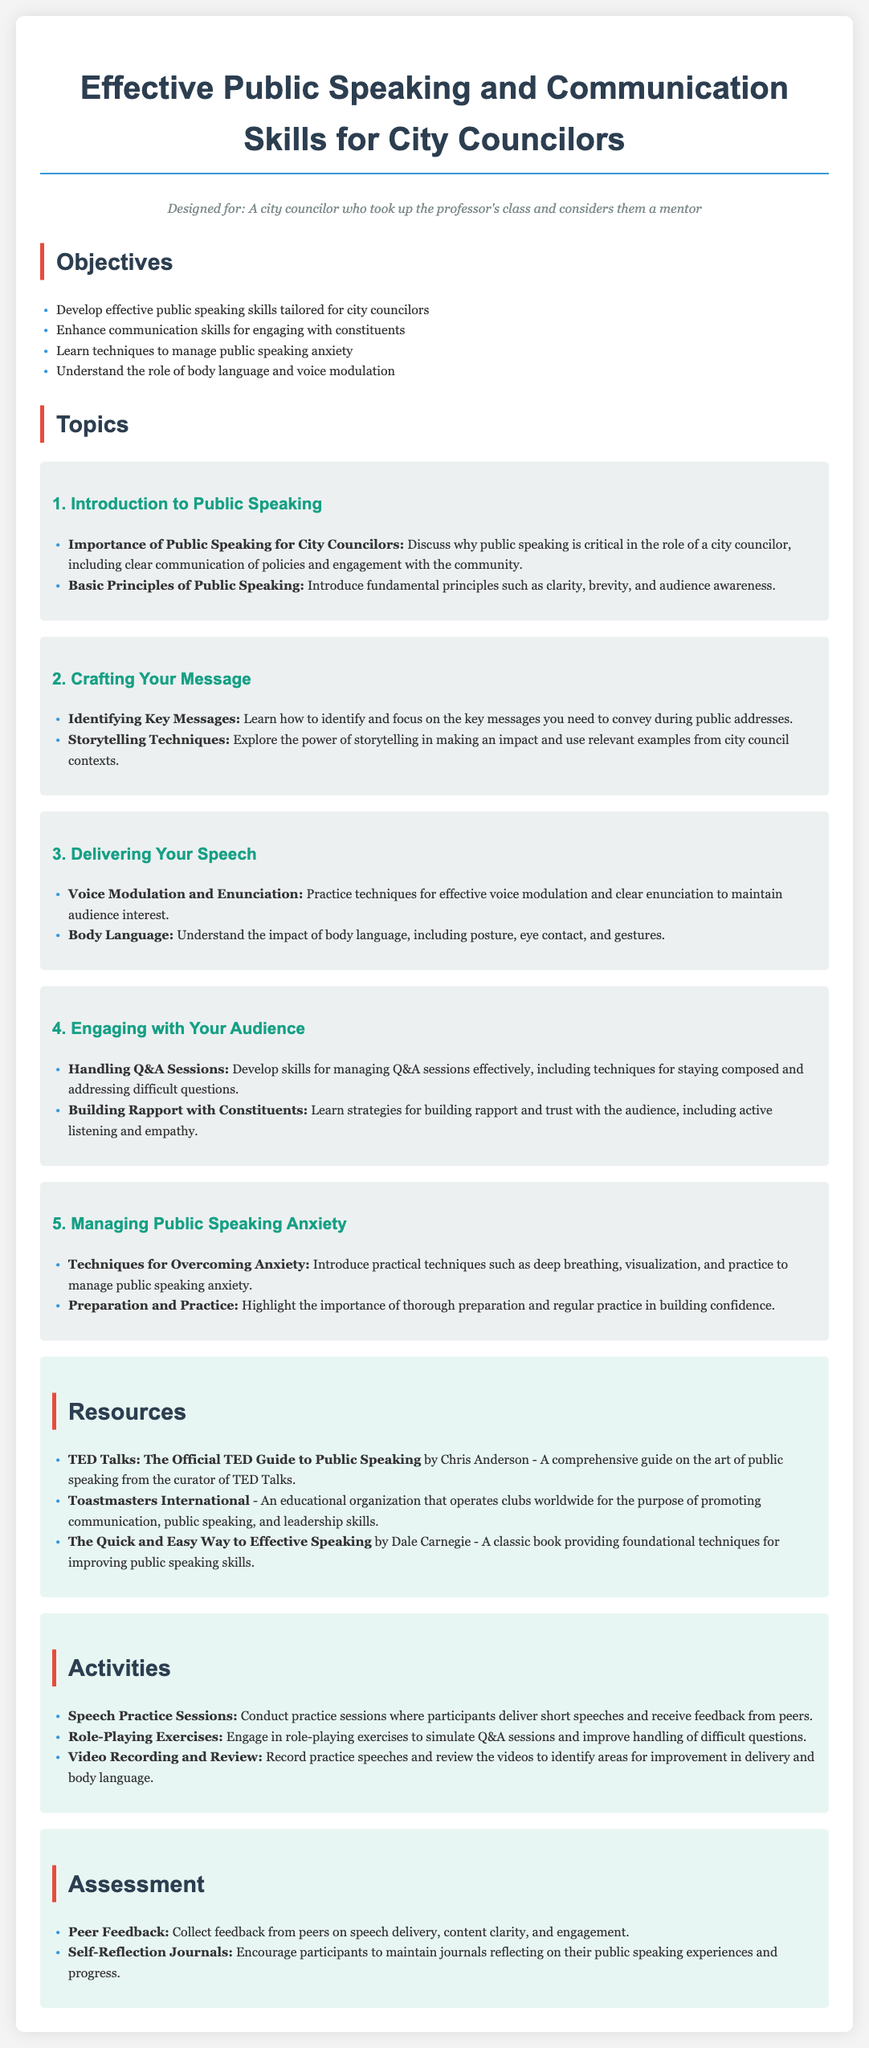What is the main title of the lesson plan? The main title is clearly stated at the top of the document, emphasizing the focus of the lesson.
Answer: Effective Public Speaking and Communication Skills for City Councilors How many objectives are listed in the lesson plan? The number of objectives can be found as they are enumerated in a bullet point list.
Answer: 4 What is a key message identified in the crafting your message topic? The topic discusses specific focal points that participants should learn to identify and convey effectively.
Answer: Identifying Key Messages What technique is suggested for managing public speaking anxiety? The document provides specific techniques within the related topic to help participants overcome anxiety.
Answer: Deep breathing Which book is recommended as a resource for improving public speaking skills? The resource section includes notable books that can aid in enhancing public speaking abilities.
Answer: The Quick and Easy Way to Effective Speaking What kind of activities are included in the lesson plan? Activities are detailed within a specific section of the document, focusing on practice and engagement methods.
Answer: Speech Practice Sessions What is the assessment method that involves collecting feedback? The assessment section outlines specific strategies used to evaluate the participants' progress.
Answer: Peer Feedback How does the lesson plan suggest building rapport with constituents? This requires understanding the importance of techniques mentioned in the relevant topic about audience engagement.
Answer: Active listening and empathy What is the first topic covered in the lesson plan? The topics are organized in a sequential manner and can hence be retrieved easily.
Answer: Introduction to Public Speaking 